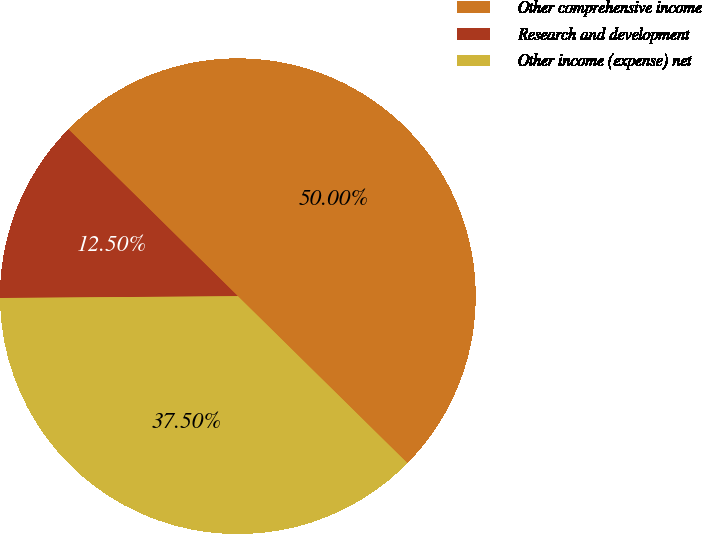Convert chart to OTSL. <chart><loc_0><loc_0><loc_500><loc_500><pie_chart><fcel>Other comprehensive income<fcel>Research and development<fcel>Other income (expense) net<nl><fcel>50.0%<fcel>12.5%<fcel>37.5%<nl></chart> 